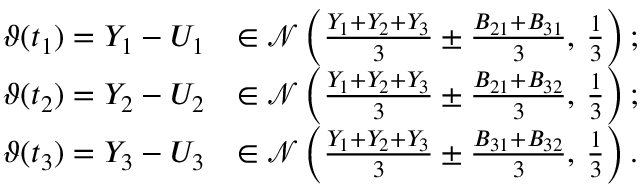<formula> <loc_0><loc_0><loc_500><loc_500>\begin{array} { r l } { \vartheta ( t _ { 1 } ) = Y _ { 1 } - U _ { 1 } } & { \in \mathcal { N } \left ( \frac { Y _ { 1 } + Y _ { 2 } + Y _ { 3 } } { 3 } \pm \frac { B _ { 2 1 } + B _ { 3 1 } } { 3 } , \, \frac { 1 } { 3 } \right ) ; } \\ { \vartheta ( t _ { 2 } ) = Y _ { 2 } - U _ { 2 } } & { \in \mathcal { N } \left ( \frac { Y _ { 1 } + Y _ { 2 } + Y _ { 3 } } { 3 } \pm \frac { B _ { 2 1 } + B _ { 3 2 } } { 3 } , \, \frac { 1 } { 3 } \right ) ; } \\ { \vartheta ( t _ { 3 } ) = Y _ { 3 } - U _ { 3 } } & { \in \mathcal { N } \left ( \frac { Y _ { 1 } + Y _ { 2 } + Y _ { 3 } } { 3 } \pm \frac { B _ { 3 1 } + B _ { 3 2 } } { 3 } , \, \frac { 1 } { 3 } \right ) . } \end{array}</formula> 